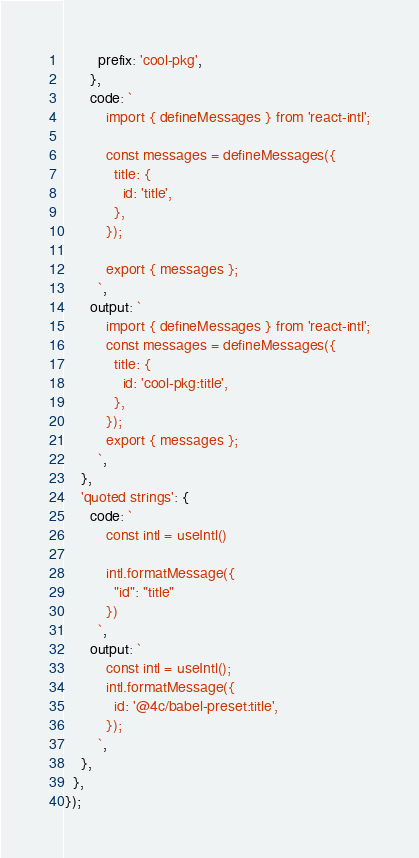<code> <loc_0><loc_0><loc_500><loc_500><_JavaScript_>        prefix: 'cool-pkg',
      },
      code: `
          import { defineMessages } from 'react-intl';

          const messages = defineMessages({
            title: {
              id: 'title',
            },
          });

          export { messages };
        `,
      output: `
          import { defineMessages } from 'react-intl';
          const messages = defineMessages({
            title: {
              id: 'cool-pkg:title',
            },
          });
          export { messages };
        `,
    },
    'quoted strings': {
      code: `
          const intl = useIntl()

          intl.formatMessage({
            "id": "title"
          })
        `,
      output: `
          const intl = useIntl();
          intl.formatMessage({
            id: '@4c/babel-preset:title',
          });
        `,
    },
  },
});
</code> 